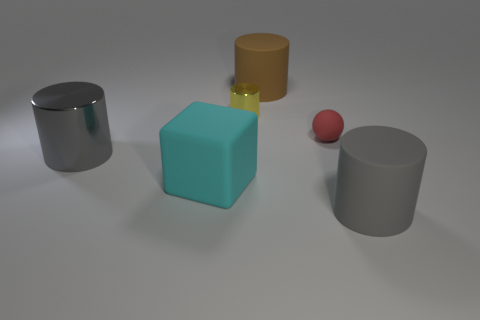Add 1 tiny brown spheres. How many objects exist? 7 Subtract all cylinders. How many objects are left? 2 Subtract 0 gray spheres. How many objects are left? 6 Subtract all tiny cyan metal cylinders. Subtract all brown matte objects. How many objects are left? 5 Add 2 brown cylinders. How many brown cylinders are left? 3 Add 2 cyan metal blocks. How many cyan metal blocks exist? 2 